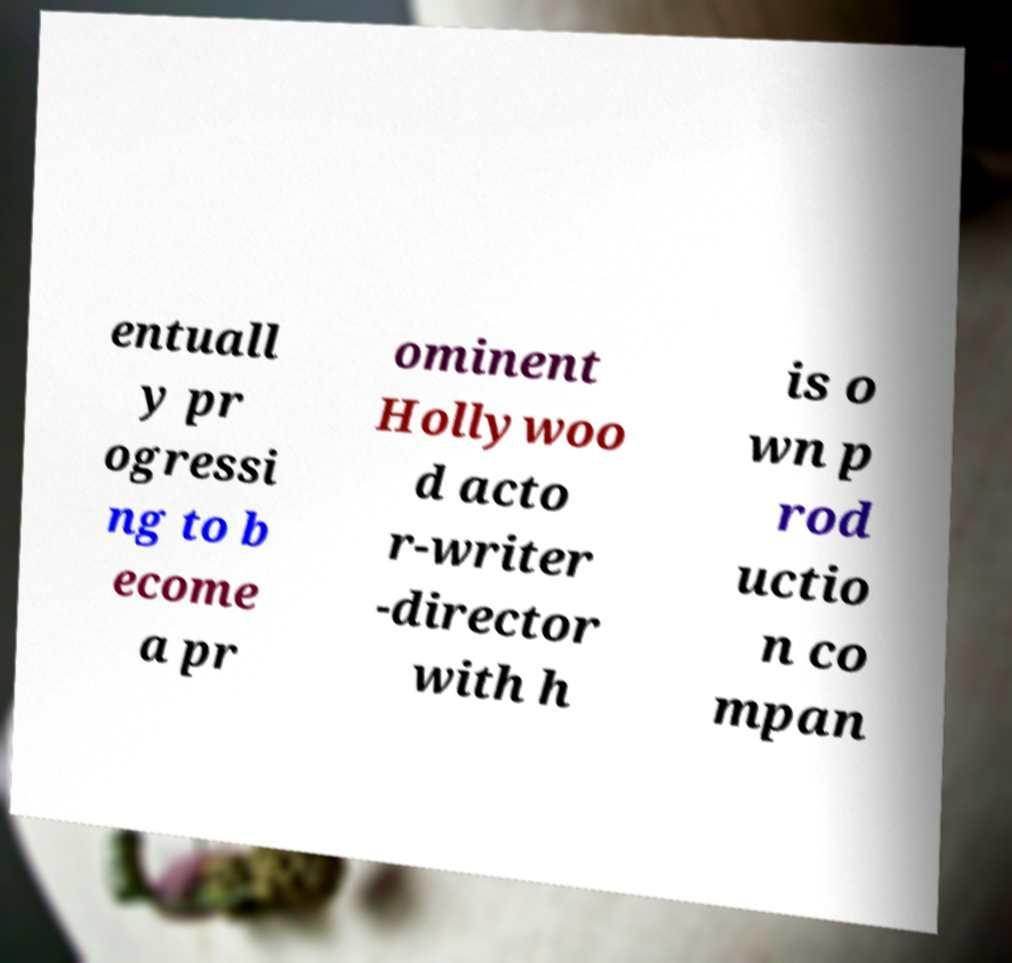Can you read and provide the text displayed in the image?This photo seems to have some interesting text. Can you extract and type it out for me? entuall y pr ogressi ng to b ecome a pr ominent Hollywoo d acto r-writer -director with h is o wn p rod uctio n co mpan 